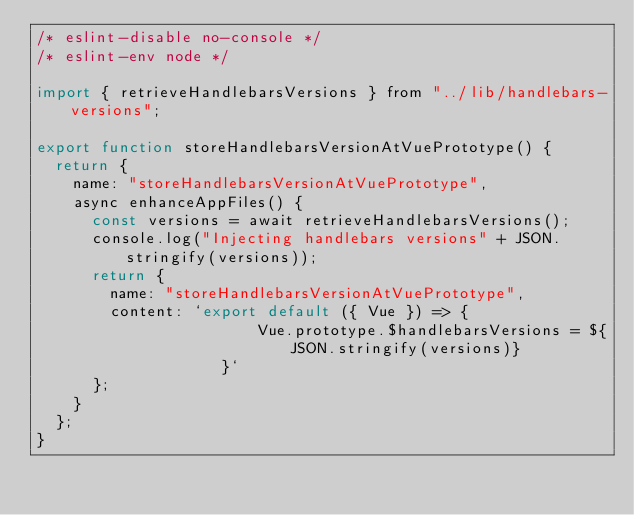Convert code to text. <code><loc_0><loc_0><loc_500><loc_500><_JavaScript_>/* eslint-disable no-console */
/* eslint-env node */

import { retrieveHandlebarsVersions } from "../lib/handlebars-versions";

export function storeHandlebarsVersionAtVuePrototype() {
  return {
    name: "storeHandlebarsVersionAtVuePrototype",
    async enhanceAppFiles() {
      const versions = await retrieveHandlebarsVersions();
      console.log("Injecting handlebars versions" + JSON.stringify(versions));
      return {
        name: "storeHandlebarsVersionAtVuePrototype",
        content: `export default ({ Vue }) => { 
                        Vue.prototype.$handlebarsVersions = ${JSON.stringify(versions)}
                    }`
      };
    }
  };
}
</code> 